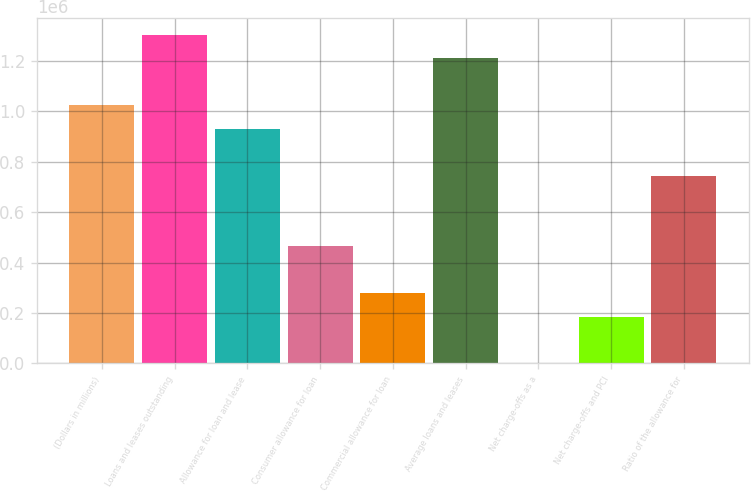<chart> <loc_0><loc_0><loc_500><loc_500><bar_chart><fcel>(Dollars in millions)<fcel>Loans and leases outstanding<fcel>Allowance for loan and lease<fcel>Consumer allowance for loan<fcel>Commercial allowance for loan<fcel>Average loans and leases<fcel>Net charge-offs as a<fcel>Net charge-offs and PCI<fcel>Ratio of the allowance for<nl><fcel>1.02414e+06<fcel>1.30345e+06<fcel>931039<fcel>465520<fcel>279312<fcel>1.21035e+06<fcel>0.44<fcel>186208<fcel>744831<nl></chart> 